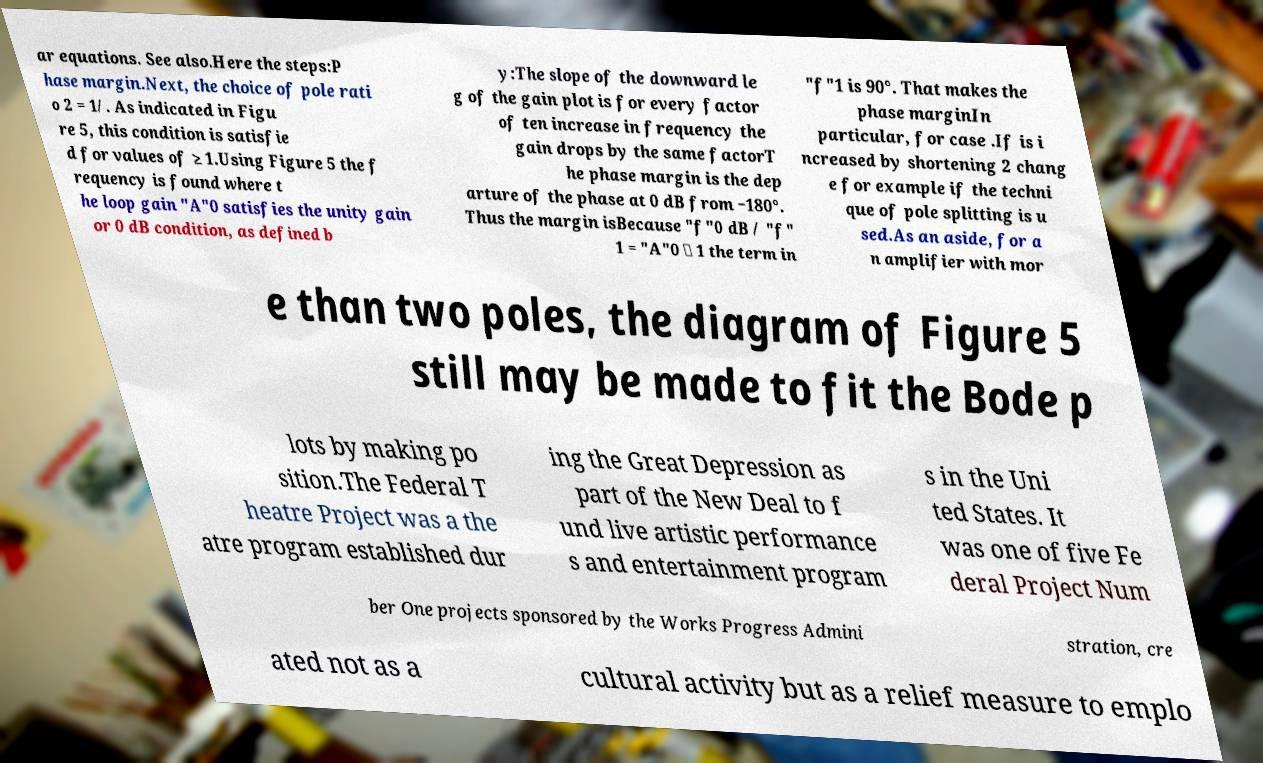Could you assist in decoding the text presented in this image and type it out clearly? ar equations. See also.Here the steps:P hase margin.Next, the choice of pole rati o 2 = 1/. As indicated in Figu re 5, this condition is satisfie d for values of ≥ 1.Using Figure 5 the f requency is found where t he loop gain "A"0 satisfies the unity gain or 0 dB condition, as defined b y:The slope of the downward le g of the gain plot is for every factor of ten increase in frequency the gain drops by the same factorT he phase margin is the dep arture of the phase at 0 dB from −180°. Thus the margin isBecause "f"0 dB / "f" 1 = "A"0 ≫ 1 the term in "f"1 is 90°. That makes the phase marginIn particular, for case .If is i ncreased by shortening 2 chang e for example if the techni que of pole splitting is u sed.As an aside, for a n amplifier with mor e than two poles, the diagram of Figure 5 still may be made to fit the Bode p lots by making po sition.The Federal T heatre Project was a the atre program established dur ing the Great Depression as part of the New Deal to f und live artistic performance s and entertainment program s in the Uni ted States. It was one of five Fe deral Project Num ber One projects sponsored by the Works Progress Admini stration, cre ated not as a cultural activity but as a relief measure to emplo 